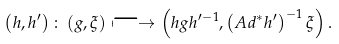Convert formula to latex. <formula><loc_0><loc_0><loc_500><loc_500>\left ( h , h ^ { \prime } \right ) \colon \left ( g , \xi \right ) \longmapsto \left ( h g h ^ { \prime - 1 } , \left ( A d ^ { * } h ^ { \prime } \right ) ^ { - 1 } \xi \right ) .</formula> 